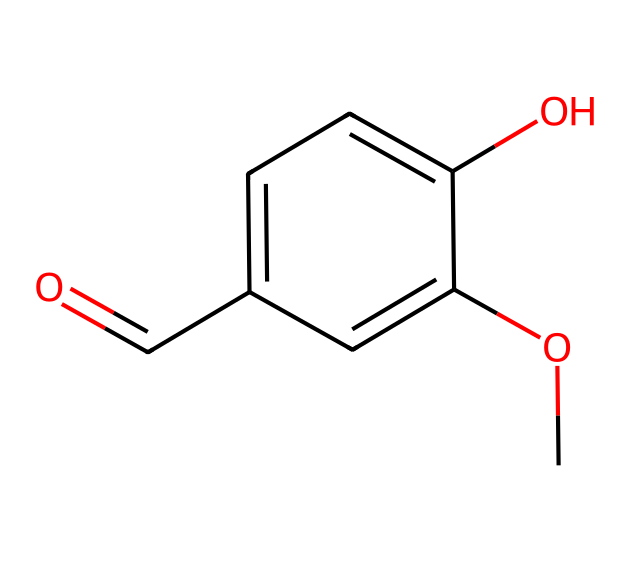What is the molecular formula of vanillin? To determine the molecular formula, count the number of each type of atom in the structure: carbon (C), hydrogen (H), and oxygen (O). There are 8 carbon atoms, 8 hydrogen atoms, and 3 oxygen atoms. Therefore, the molecular formula is C8H8O3.
Answer: C8H8O3 How many rings are present in the structure of vanillin? The structure does not contain any cyclic (ring) formations; it is entirely acyclic. Thus, the number of rings is zero.
Answer: 0 What functional groups are present in vanillin? Identify the key functional groups by looking at the various groups attached to the carbon backbone: there is a hydroxyl group (-OH), an aldehyde group (-CHO), and a methoxy group (-OCH3). This indicates multiple functional groups are present.
Answer: hydroxyl, aldehyde, methoxy What is the total number of atom types in vanillin? By examining the structure, identify the different types of atoms present: carbon (C), hydrogen (H), and oxygen (O). Each type of atom counts as one type, resulting in three unique atom types in the molecule.
Answer: 3 How many double bonds are in the vanillin structure? Analyze the structure to find double bonds. The molecule has one double bond in the carbonyl group (C=O) and one in the aromatic ring (C=C). Summing these gives a total of two double bonds.
Answer: 2 What makes vanillin a flavoring agent? Vanillin's distinct aromatic aldehyde structure is responsible for its sweet, pleasant flavor, commonly associated with vanilla. This characteristic is derived from its specific arrangement of atoms, particularly the aromatic ring and the aldehyde functional group.
Answer: aromatic aldehyde Is vanillin natural or synthetic? Vanillin can be derived from natural sources (like vanilla beans) or produced synthetically. The specific method of production determines its classification, but the structure does not indicate its source directly. Therefore, while typically synthetic in many products, it can also be natural.
Answer: both 